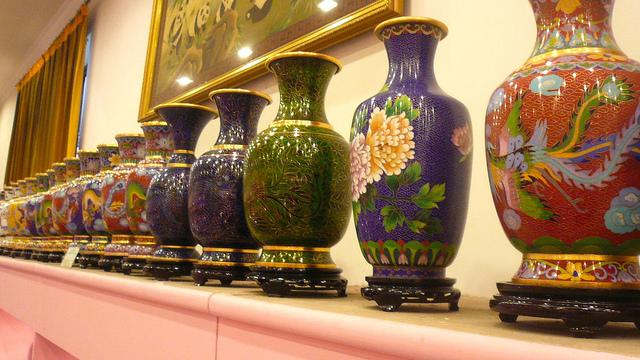How many cases are on the mantle?
Answer briefly. 17. Is this someone's home or a museum?
Quick response, please. Museum. What color is the mantle?
Write a very short answer. Pink. 